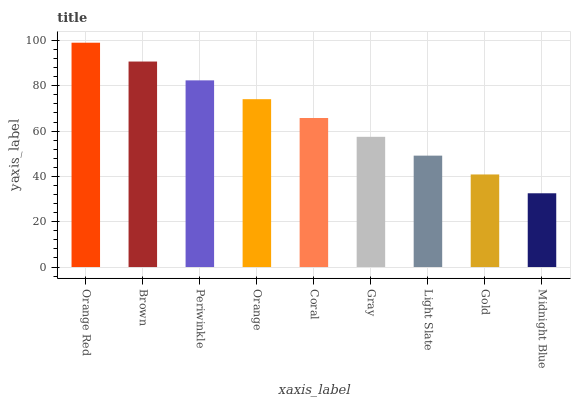Is Midnight Blue the minimum?
Answer yes or no. Yes. Is Orange Red the maximum?
Answer yes or no. Yes. Is Brown the minimum?
Answer yes or no. No. Is Brown the maximum?
Answer yes or no. No. Is Orange Red greater than Brown?
Answer yes or no. Yes. Is Brown less than Orange Red?
Answer yes or no. Yes. Is Brown greater than Orange Red?
Answer yes or no. No. Is Orange Red less than Brown?
Answer yes or no. No. Is Coral the high median?
Answer yes or no. Yes. Is Coral the low median?
Answer yes or no. Yes. Is Midnight Blue the high median?
Answer yes or no. No. Is Orange Red the low median?
Answer yes or no. No. 